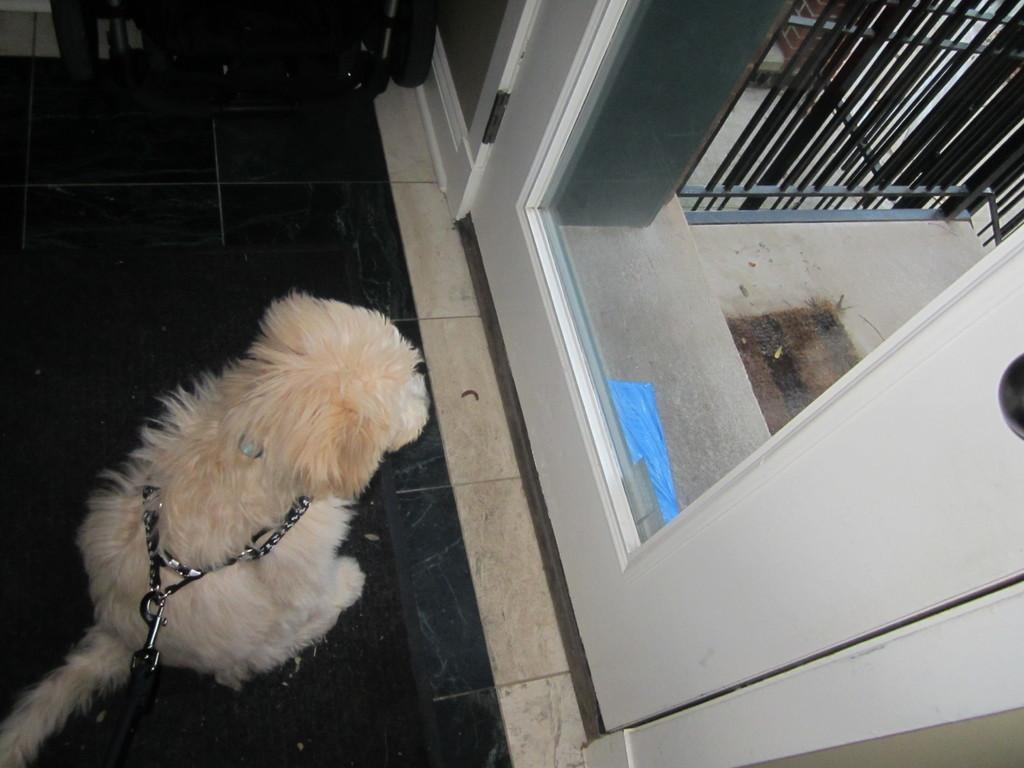Could you give a brief overview of what you see in this image? In the center of the image, we can see a dog with chain and in the background, there are doors, grills and some objects. At the bottom, there is floor. 